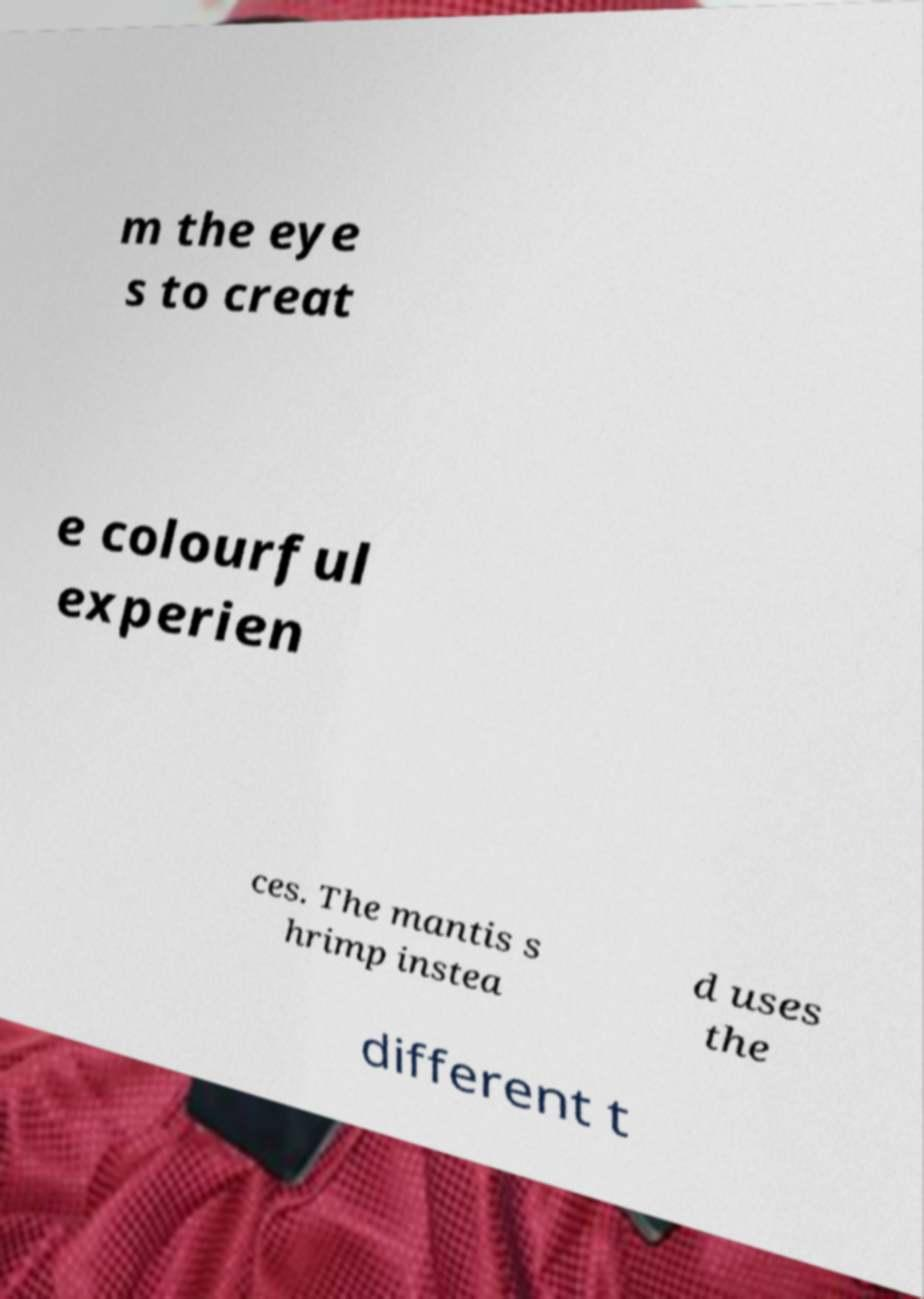Can you read and provide the text displayed in the image?This photo seems to have some interesting text. Can you extract and type it out for me? m the eye s to creat e colourful experien ces. The mantis s hrimp instea d uses the different t 